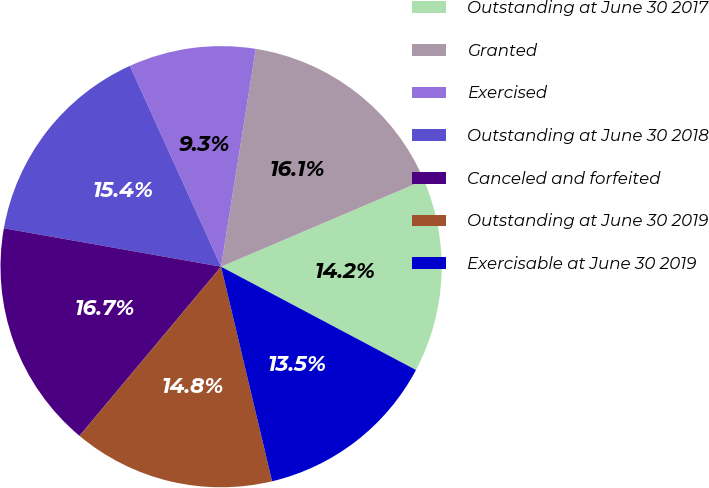Convert chart to OTSL. <chart><loc_0><loc_0><loc_500><loc_500><pie_chart><fcel>Outstanding at June 30 2017<fcel>Granted<fcel>Exercised<fcel>Outstanding at June 30 2018<fcel>Canceled and forfeited<fcel>Outstanding at June 30 2019<fcel>Exercisable at June 30 2019<nl><fcel>14.17%<fcel>16.07%<fcel>9.3%<fcel>15.43%<fcel>16.7%<fcel>14.8%<fcel>13.53%<nl></chart> 